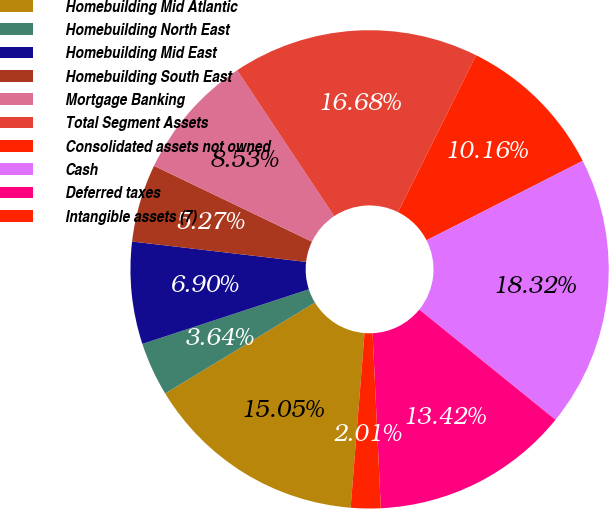Convert chart to OTSL. <chart><loc_0><loc_0><loc_500><loc_500><pie_chart><fcel>Homebuilding Mid Atlantic<fcel>Homebuilding North East<fcel>Homebuilding Mid East<fcel>Homebuilding South East<fcel>Mortgage Banking<fcel>Total Segment Assets<fcel>Consolidated assets not owned<fcel>Cash<fcel>Deferred taxes<fcel>Intangible assets (7)<nl><fcel>15.05%<fcel>3.64%<fcel>6.9%<fcel>5.27%<fcel>8.53%<fcel>16.68%<fcel>10.16%<fcel>18.32%<fcel>13.42%<fcel>2.01%<nl></chart> 